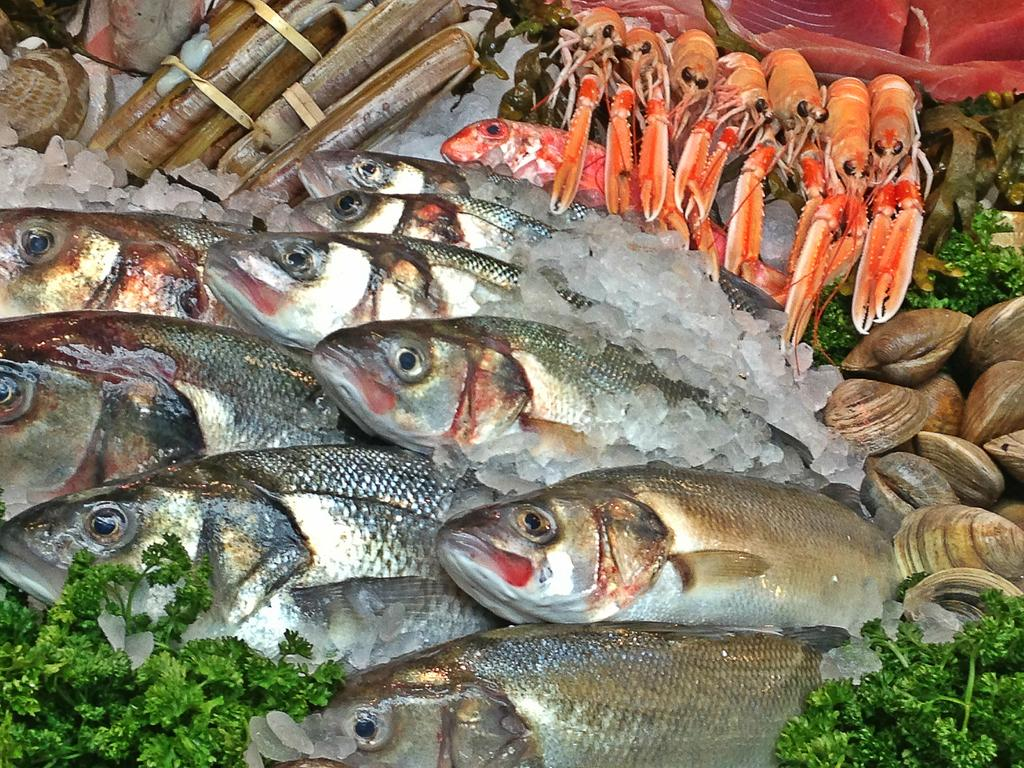What type of animals can be seen in the image? There are fish in the image. What other elements are present in the image besides the fish? Vegetable leaves and ice are visible in the image. Can you describe the food items in the image? Food items are visible in the image, but their specific nature is not clear from the provided facts. What type of brass instrument can be heard playing in the background of the image? There is no brass instrument or sound present in the image; it features fish, vegetable leaves, and ice. 